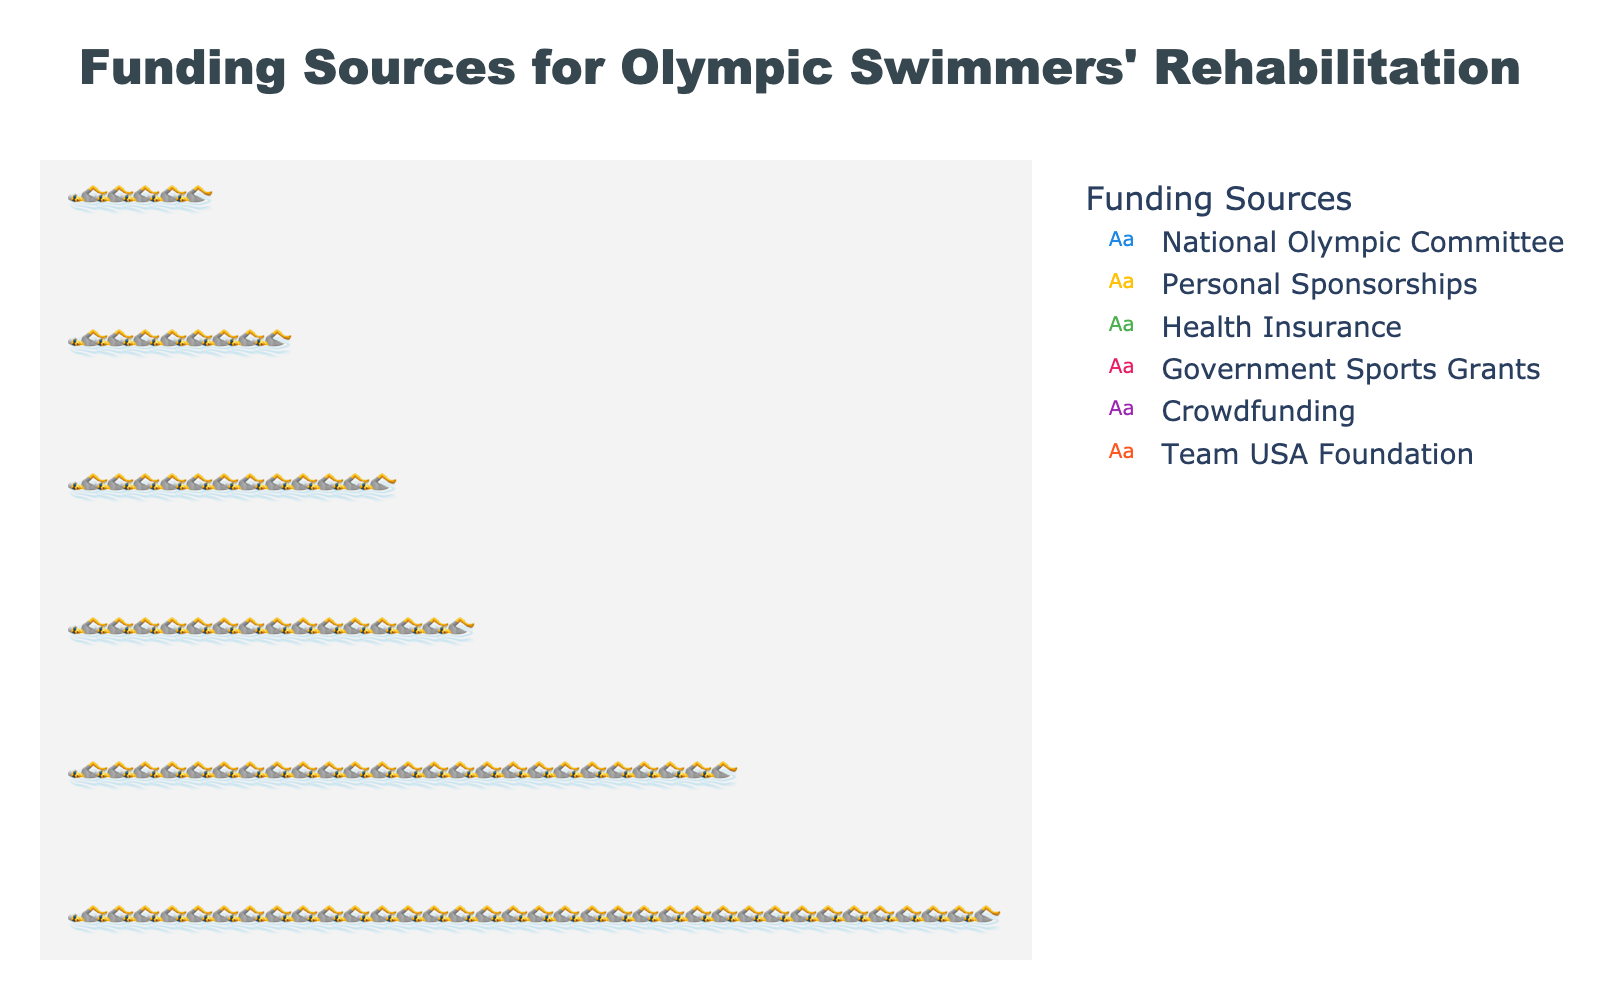How many funding sources are depicted in the figure? Each row in the plot corresponds to a different funding source, and there are six rows.
Answer: 6 Which funding source contributes the largest percentage? The "National Olympic Committee" row has the highest number of icons, indicating the largest contribution.
Answer: National Olympic Committee What is the total percentage contributed by personal sponsorships and health insurance? Personal Sponsorships contribute 25%, and Health Insurance contributes 15%. Adding these together, 25% + 15% = 40%.
Answer: 40% Which funding source has the smallest contribution, and what is its percentage? The "Team USA Foundation" row has the fewest icons, indicating the smallest contribution at 5%.
Answer: Team USA Foundation, 5% By how much does government sports grants' contribution exceed that of crowdfunding? Government Sports Grants contribute 12%, while Crowdfunding contributes 8%. The difference is 12% - 8% = 4%.
Answer: 4% What percentage of funding is contributed by sources other than the National Olympic Committee? The National Olympic Committee contributes 35%. The total funding percentage is 100%, so other sources contribute 100% - 35% = 65%.
Answer: 65% How many icons are used to represent the total funding contribution? Each icon represents 1% of the total funding, and the total percentage is 100%, so there are 100 icons.
Answer: 100 Which two funding sources contribute equally, and what is their contribution percentage? The plot shows that no two funding sources contribute the same percentage.
Answer: None What is the difference between the contributions of the top two funding sources? The top two funding sources are the National Olympic Committee (35%) and Personal Sponsorships (25%). Their difference is 35% - 25% = 10%.
Answer: 10% If Crowdfunding increases by 4% next year, how will its contribution compare with Health Insurance? Crowdfunding currently contributes 8%. If it increases by 4%, it will contribute 12%, which will equal Health Insurance's current contribution of 12%.
Answer: Equal 